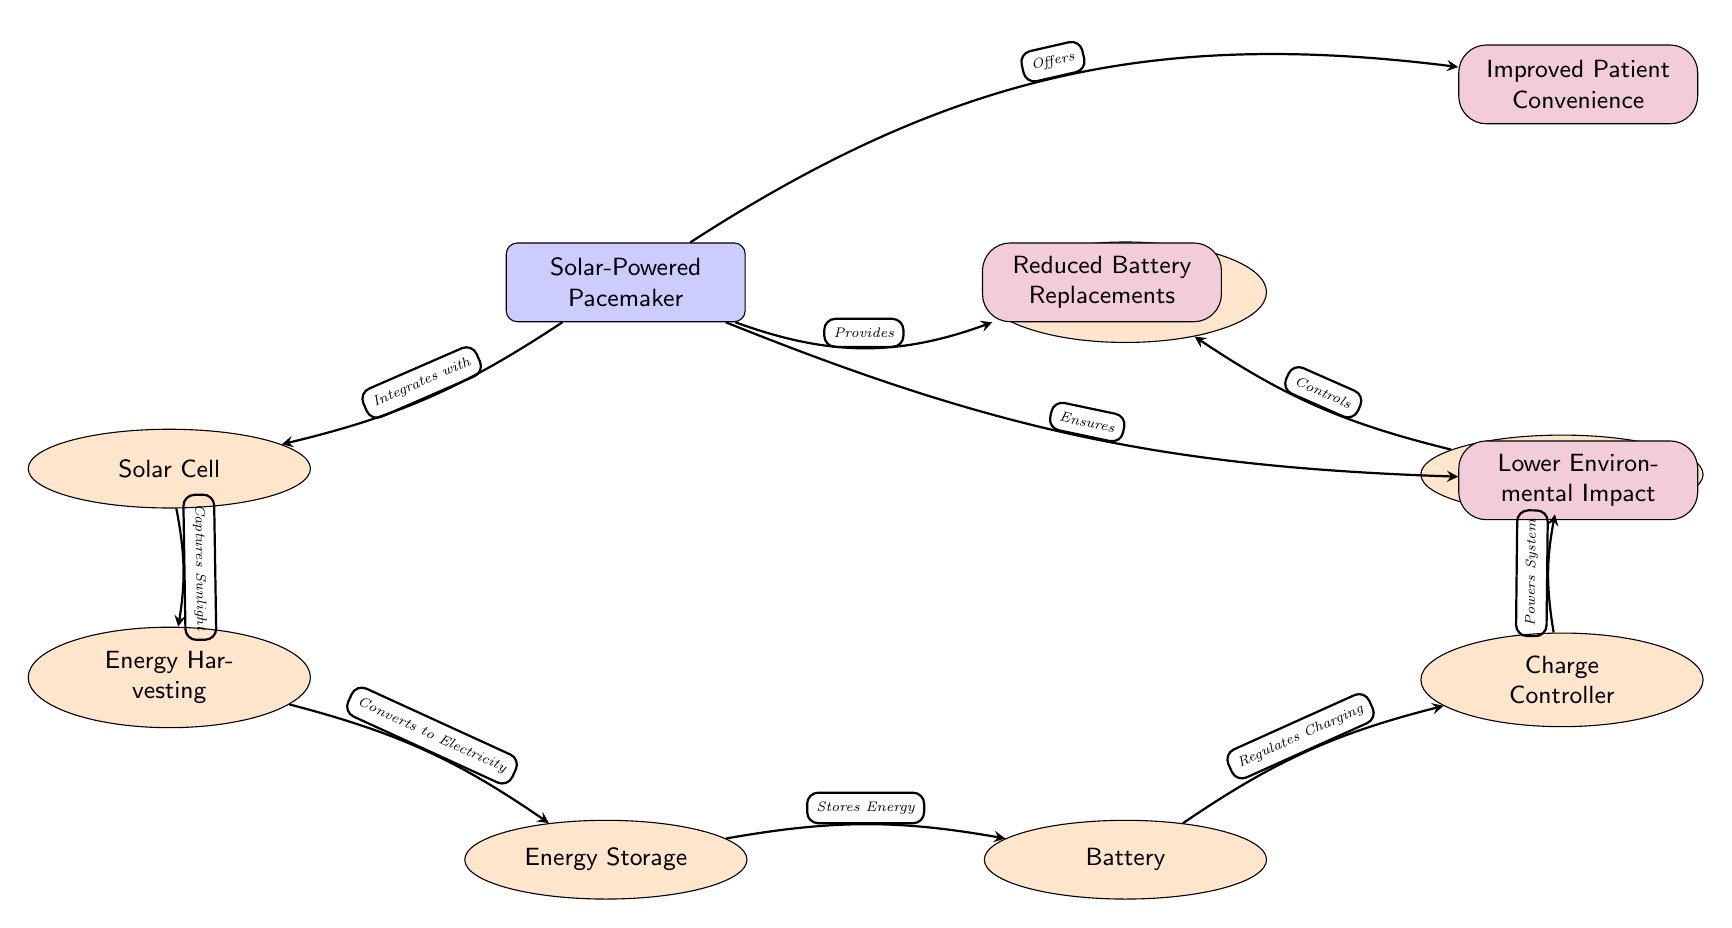What is the main component of the diagram? The main component, identified at the center of the diagram, is "Solar-Powered Pacemaker."
Answer: Solar-Powered Pacemaker How many components are connected to the main pacemaker? There are a total of 6 components directly connected to the main node. The components are Solar Cell, Energy Harvesting, Energy Storage, Battery, Charge Controller, and Pulse Generation.
Answer: 6 What does the solar cell do? The solar cell captures sunlight and sends it to the energy harvesting unit to convert it into electricity.
Answer: Captures Sunlight Which component regulates the charging of the battery? The Charge Controller is responsible for regulating the charging of the battery.
Answer: Charge Controller What are the three benefits listed for the pacemaker? The benefits listed are Reduced Battery Replacements, Lower Environmental Impact, and Improved Patient Convenience.
Answer: Reduced Battery Replacements, Lower Environmental Impact, Improved Patient Convenience How does the pulse generation component relate to heartbeat regulation? The Pulse Generation component controls the heartbeat regulation, indicating a flow where pulse generation influences heartbeat functions.
Answer: Controls What is the role of energy storage in the system? Energy Storage is responsible for storing the electricity generated from the energy harvesting process.
Answer: Stores Energy How does the pacemaker ensure a lower environmental impact? The pacemaker ensures a lower environmental impact by utilizing solar energy, leading to reduced reliance on disposable batteries.
Answer: Ensures Which component comes directly after the energy harvesting component? The Energy Storage component immediately follows the Energy Harvesting component in the process flow.
Answer: Energy Storage What benefit does the solar-powered pacemaker offer regarding battery management? It offers reduced battery replacements, which decreases maintenance needs and enhances patient convenience.
Answer: Reduced Battery Replacements 